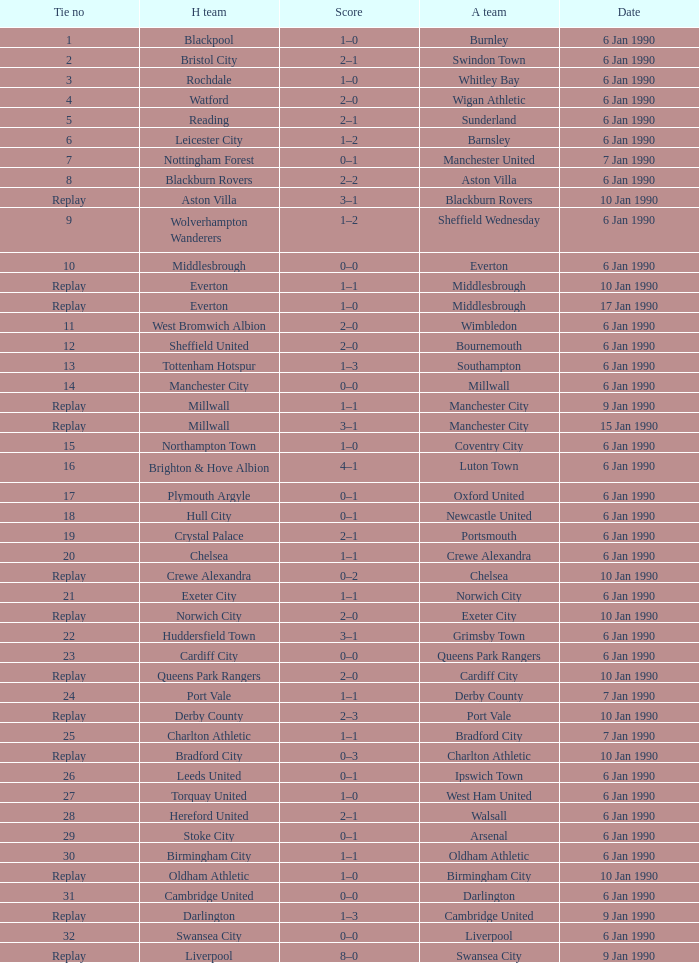What is the score of the game against away team exeter city on 10 jan 1990? 2–0. 